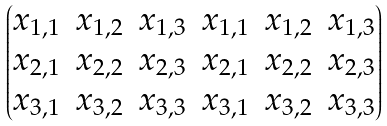Convert formula to latex. <formula><loc_0><loc_0><loc_500><loc_500>\begin{pmatrix} x _ { 1 , 1 } & x _ { 1 , 2 } & x _ { 1 , 3 } & x _ { 1 , 1 } & x _ { 1 , 2 } & x _ { 1 , 3 } \\ x _ { 2 , 1 } & x _ { 2 , 2 } & x _ { 2 , 3 } & x _ { 2 , 1 } & x _ { 2 , 2 } & x _ { 2 , 3 } \\ x _ { 3 , 1 } & x _ { 3 , 2 } & x _ { 3 , 3 } & x _ { 3 , 1 } & x _ { 3 , 2 } & x _ { 3 , 3 } \end{pmatrix}</formula> 